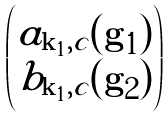Convert formula to latex. <formula><loc_0><loc_0><loc_500><loc_500>\begin{pmatrix} a _ { \mathbf k _ { 1 } , c } ( \mathbf g _ { 1 } ) \\ b _ { \mathbf k _ { 1 } , c } ( \mathbf g _ { 2 } ) \end{pmatrix}</formula> 